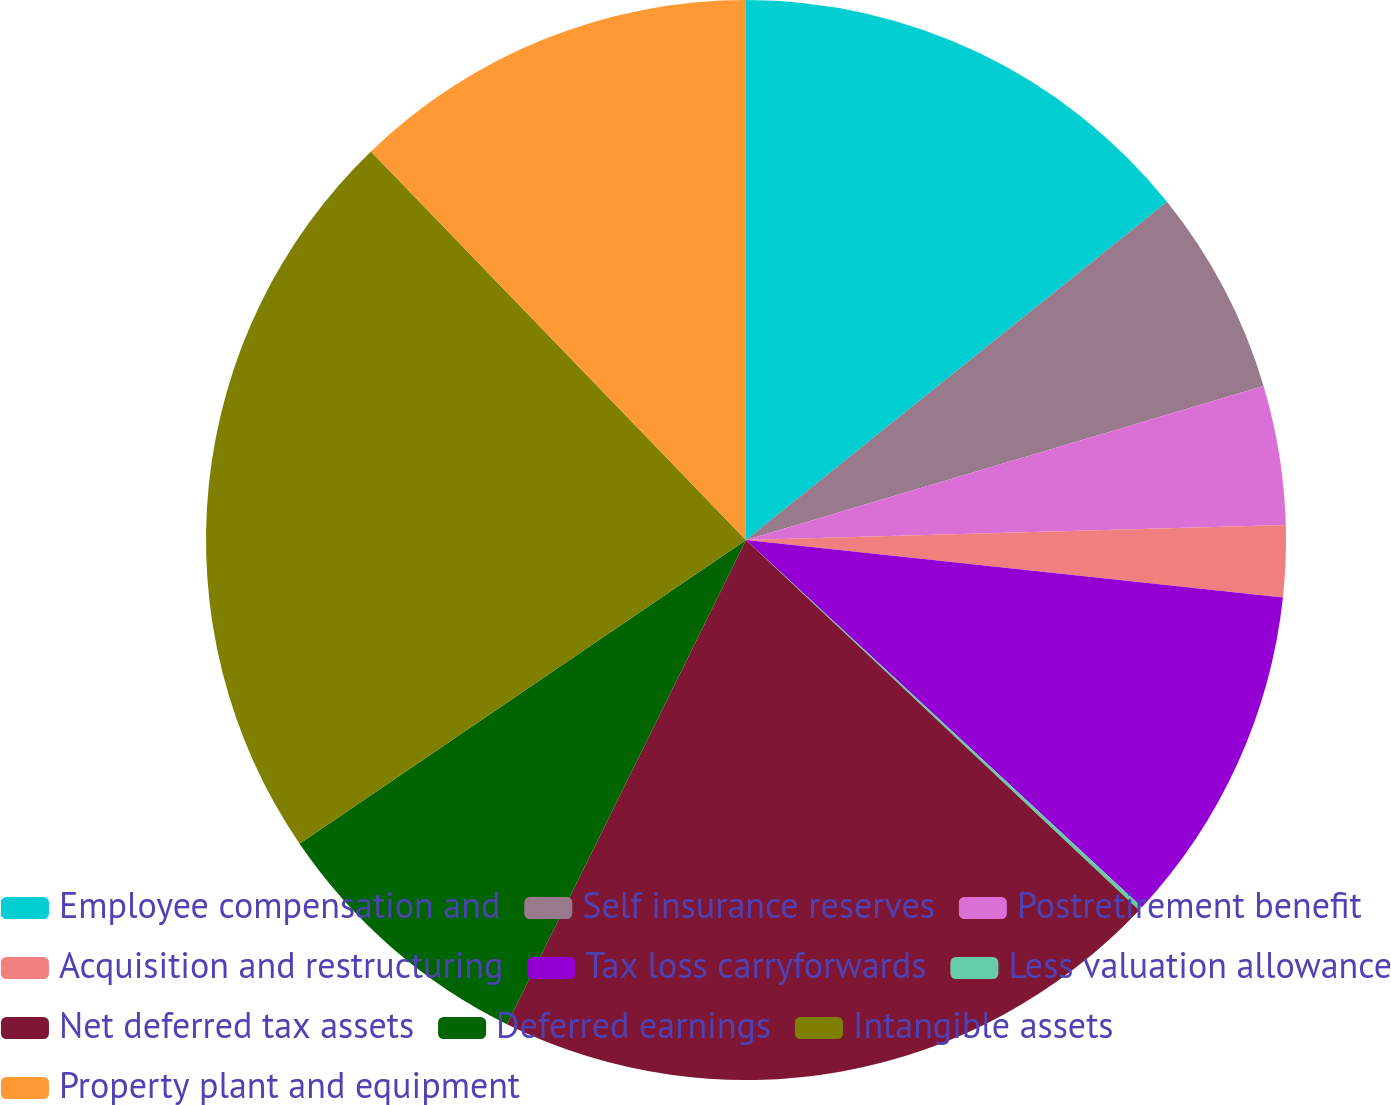<chart> <loc_0><loc_0><loc_500><loc_500><pie_chart><fcel>Employee compensation and<fcel>Self insurance reserves<fcel>Postretirement benefit<fcel>Acquisition and restructuring<fcel>Tax loss carryforwards<fcel>Less valuation allowance<fcel>Net deferred tax assets<fcel>Deferred earnings<fcel>Intangible assets<fcel>Property plant and equipment<nl><fcel>14.23%<fcel>6.17%<fcel>4.16%<fcel>2.14%<fcel>10.2%<fcel>0.12%<fcel>20.28%<fcel>8.19%<fcel>22.29%<fcel>12.22%<nl></chart> 